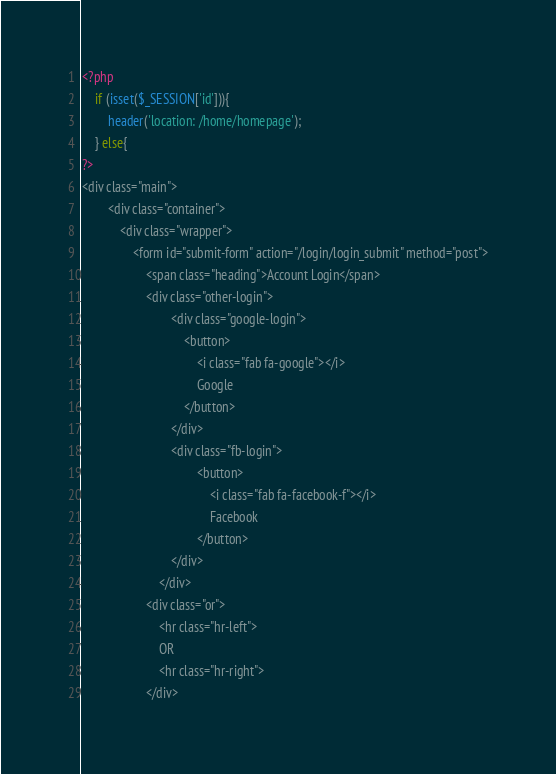<code> <loc_0><loc_0><loc_500><loc_500><_PHP_>
<?php 
    if (isset($_SESSION['id'])){
        header('location: /home/homepage');
    } else{
?>
<div class="main">
        <div class="container">
            <div class="wrapper">
                <form id="submit-form" action="/login/login_submit" method="post">
                    <span class="heading">Account Login</span>
                    <div class="other-login">
                            <div class="google-login">
                                <button>
                                    <i class="fab fa-google"></i>
                                    Google
                                </button>
                            </div>
                            <div class="fb-login">
                                    <button>
                                        <i class="fab fa-facebook-f"></i>
                                        Facebook
                                    </button>
                            </div>
                        </div>
                    <div class="or">
                        <hr class="hr-left">
                        OR
                        <hr class="hr-right">
                    </div></code> 